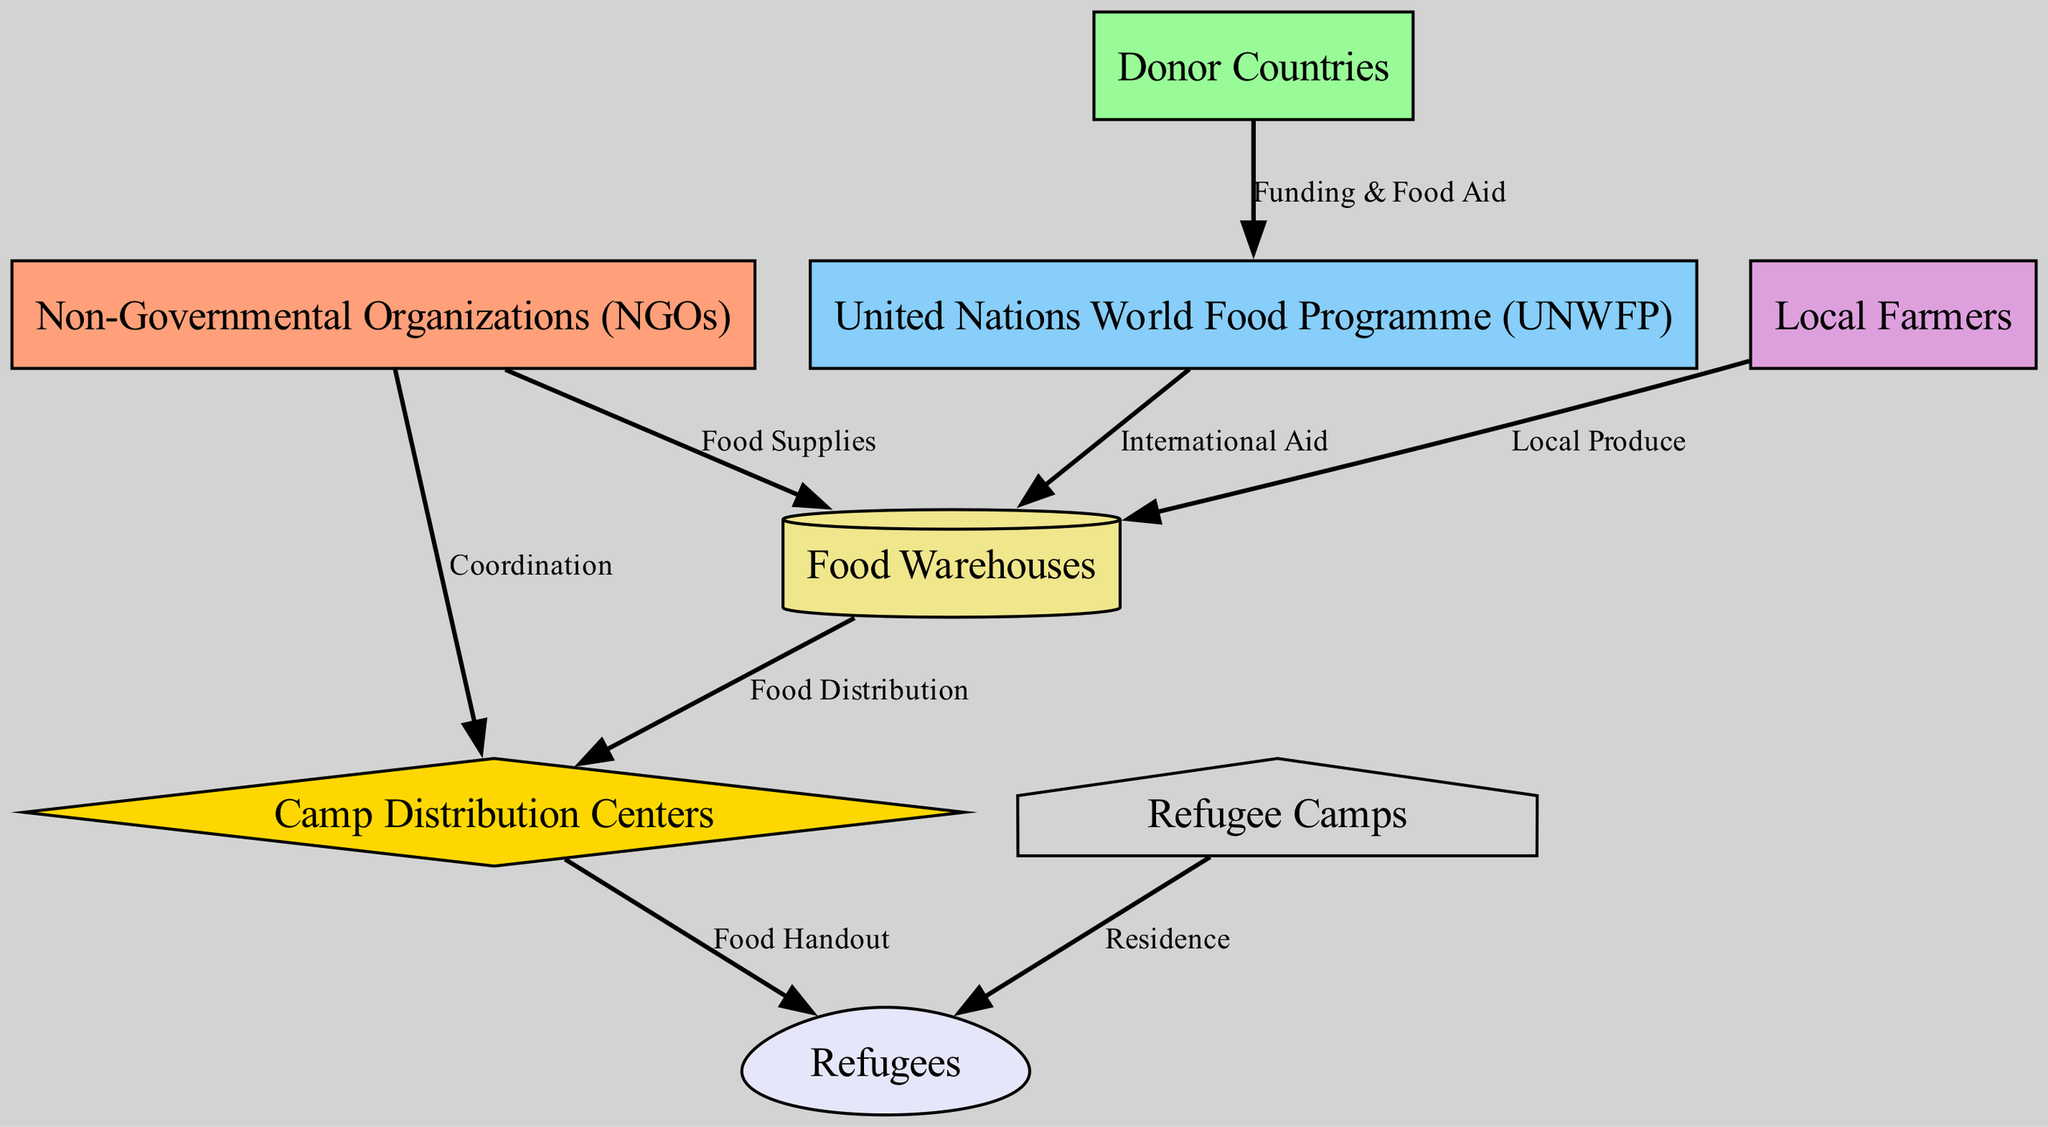What are the main organizations providing food aid? The diagram illustrates multiple nodes, but specifically, the two main organizations providing food aid are NGOs and the United Nations World Food Programme. They are distinctly labeled and play crucial roles in the distribution network.
Answer: NGOs, UNWFP How many distinct nodes are represented in the diagram? The diagram includes several distinct entities involved in the food distribution network. Upon counting each labeled entity, we find a total of eight unique nodes.
Answer: 8 Who funds the UNWFP? According to the diagram, the donor countries play a crucial role in funding the United Nations World Food Programme. This direct connection shows that they provide the necessary financial support for food aid initiatives.
Answer: Donor Countries What is the purpose of Camp Distribution Centers? The Camp Distribution Centers are specifically designed to facilitate the distribution of food to refugees. They serve as an intermediary point between the food warehouses and the final recipients, ensuring organized and efficient food handouts.
Answer: Food Handout Which node is responsible for local food supply? The diagram clearly attributes the responsibility of supplying local produce to the Local Farmers. This node connects directly to the Food Warehouses, indicating their role in contributing to the food supply.
Answer: Local Farmers Describe the relationship between Food Warehouses and Camp Distribution Centers. The Food Warehouses supply food directly to the Camp Distribution Centers. This relationship indicates that the warehouses act as storage and distribution hubs, transferring food supplies for further distribution to refugees.
Answer: Food Distribution What do NGOs contribute to food warehousing? NGOs are depicted as providers of food supplies to the Food Warehouses. This connection suggests that they play an essential part in sourcing food items to be stored and subsequently distributed within the refugee camps.
Answer: Food Supplies How do refugees receive food in the camps? The diagram illustrates that refugees receive food via Camp Distribution Centers. This step shows how food is handed out to refugees after being processed and organized for distribution at the camps.
Answer: Food Handout 